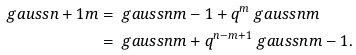<formula> <loc_0><loc_0><loc_500><loc_500>\ g a u s s { n + 1 } { m } & = \ g a u s s { n } { m - 1 } + q ^ { m } \ g a u s s { n } { m } \\ & = \ g a u s s { n } { m } + q ^ { n - m + 1 } \ g a u s s { n } { m - 1 } .</formula> 